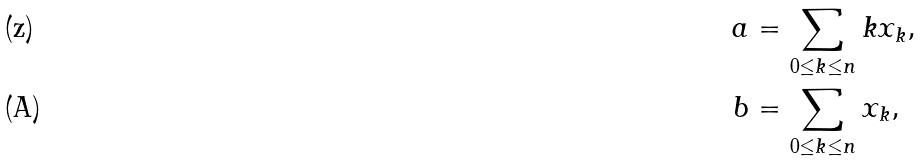Convert formula to latex. <formula><loc_0><loc_0><loc_500><loc_500>a & = \sum _ { 0 \leq k \leq n } k x _ { k } , \\ b & = \sum _ { 0 \leq k \leq n } x _ { k } ,</formula> 